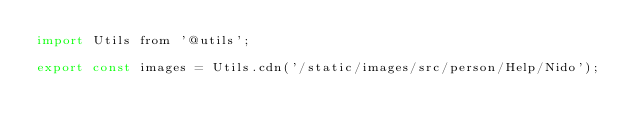Convert code to text. <code><loc_0><loc_0><loc_500><loc_500><_JavaScript_>import Utils from '@utils';

export const images = Utils.cdn('/static/images/src/person/Help/Nido');
</code> 